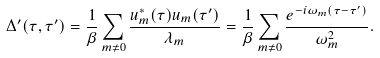<formula> <loc_0><loc_0><loc_500><loc_500>\Delta ^ { \prime } ( \tau , \tau ^ { \prime } ) = \frac { 1 } { \beta } \sum _ { m \neq 0 } \frac { u _ { m } ^ { * } ( \tau ) u _ { m } ( \tau ^ { \prime } ) } { \lambda _ { m } } = \frac { 1 } { \beta } \sum _ { m \neq 0 } \frac { e ^ { - i \omega _ { m } ( \tau - \tau ^ { \prime } ) } } { \omega _ { m } ^ { 2 } } .</formula> 